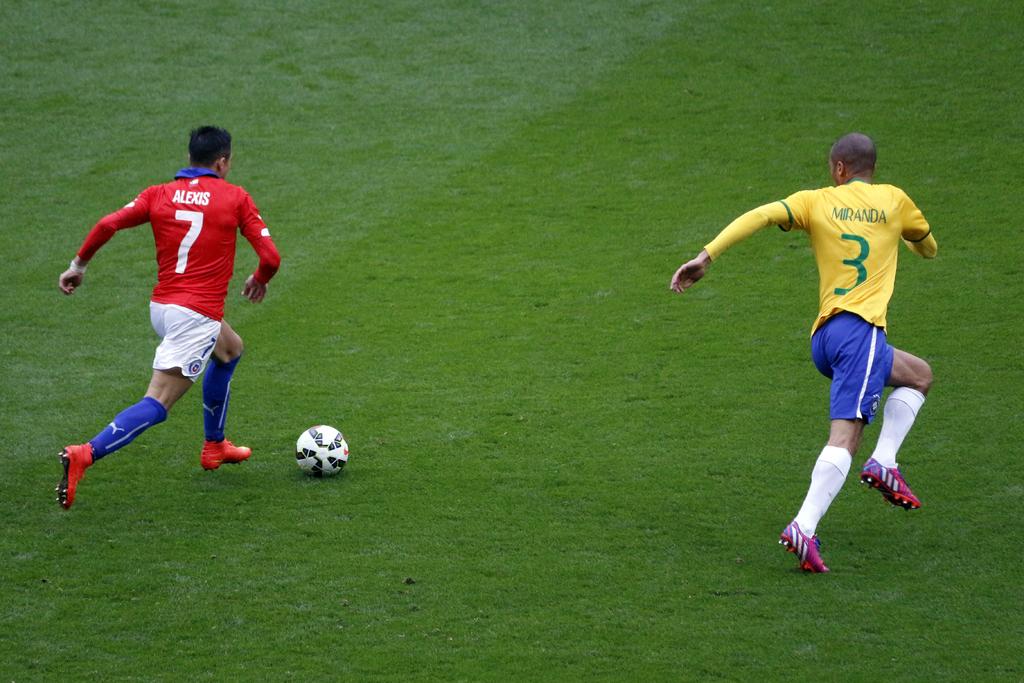What is the name of the player in red?
Your answer should be compact. Alexis. What number is on the yellow jersey?
Make the answer very short. 3. 